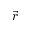Convert formula to latex. <formula><loc_0><loc_0><loc_500><loc_500>\vec { r }</formula> 